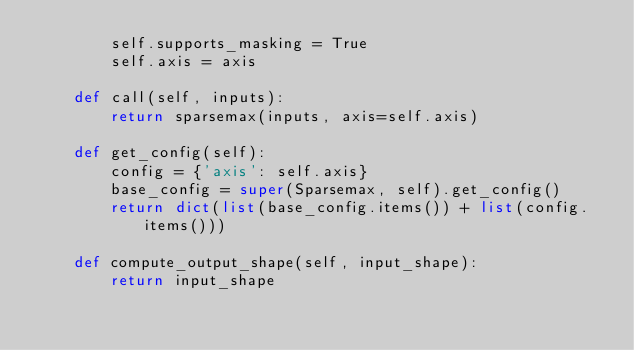<code> <loc_0><loc_0><loc_500><loc_500><_Python_>        self.supports_masking = True
        self.axis = axis

    def call(self, inputs):
        return sparsemax(inputs, axis=self.axis)

    def get_config(self):
        config = {'axis': self.axis}
        base_config = super(Sparsemax, self).get_config()
        return dict(list(base_config.items()) + list(config.items()))

    def compute_output_shape(self, input_shape):
        return input_shape
</code> 